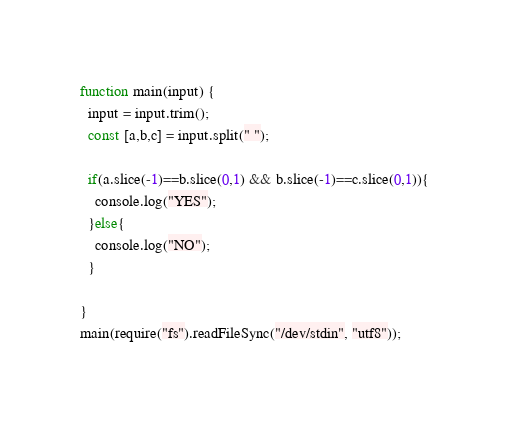<code> <loc_0><loc_0><loc_500><loc_500><_JavaScript_>function main(input) {
  input = input.trim();
  const [a,b,c] = input.split(" ");
 
  if(a.slice(-1)==b.slice(0,1) && b.slice(-1)==c.slice(0,1)){
    console.log("YES");
  }else{
    console.log("NO");
  }
 
}
main(require("fs").readFileSync("/dev/stdin", "utf8"));</code> 